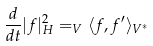Convert formula to latex. <formula><loc_0><loc_0><loc_500><loc_500>\frac { d } { d t } | f | _ { H } ^ { 2 } = _ { V } \langle f , f ^ { \prime } \rangle _ { V ^ { * } }</formula> 